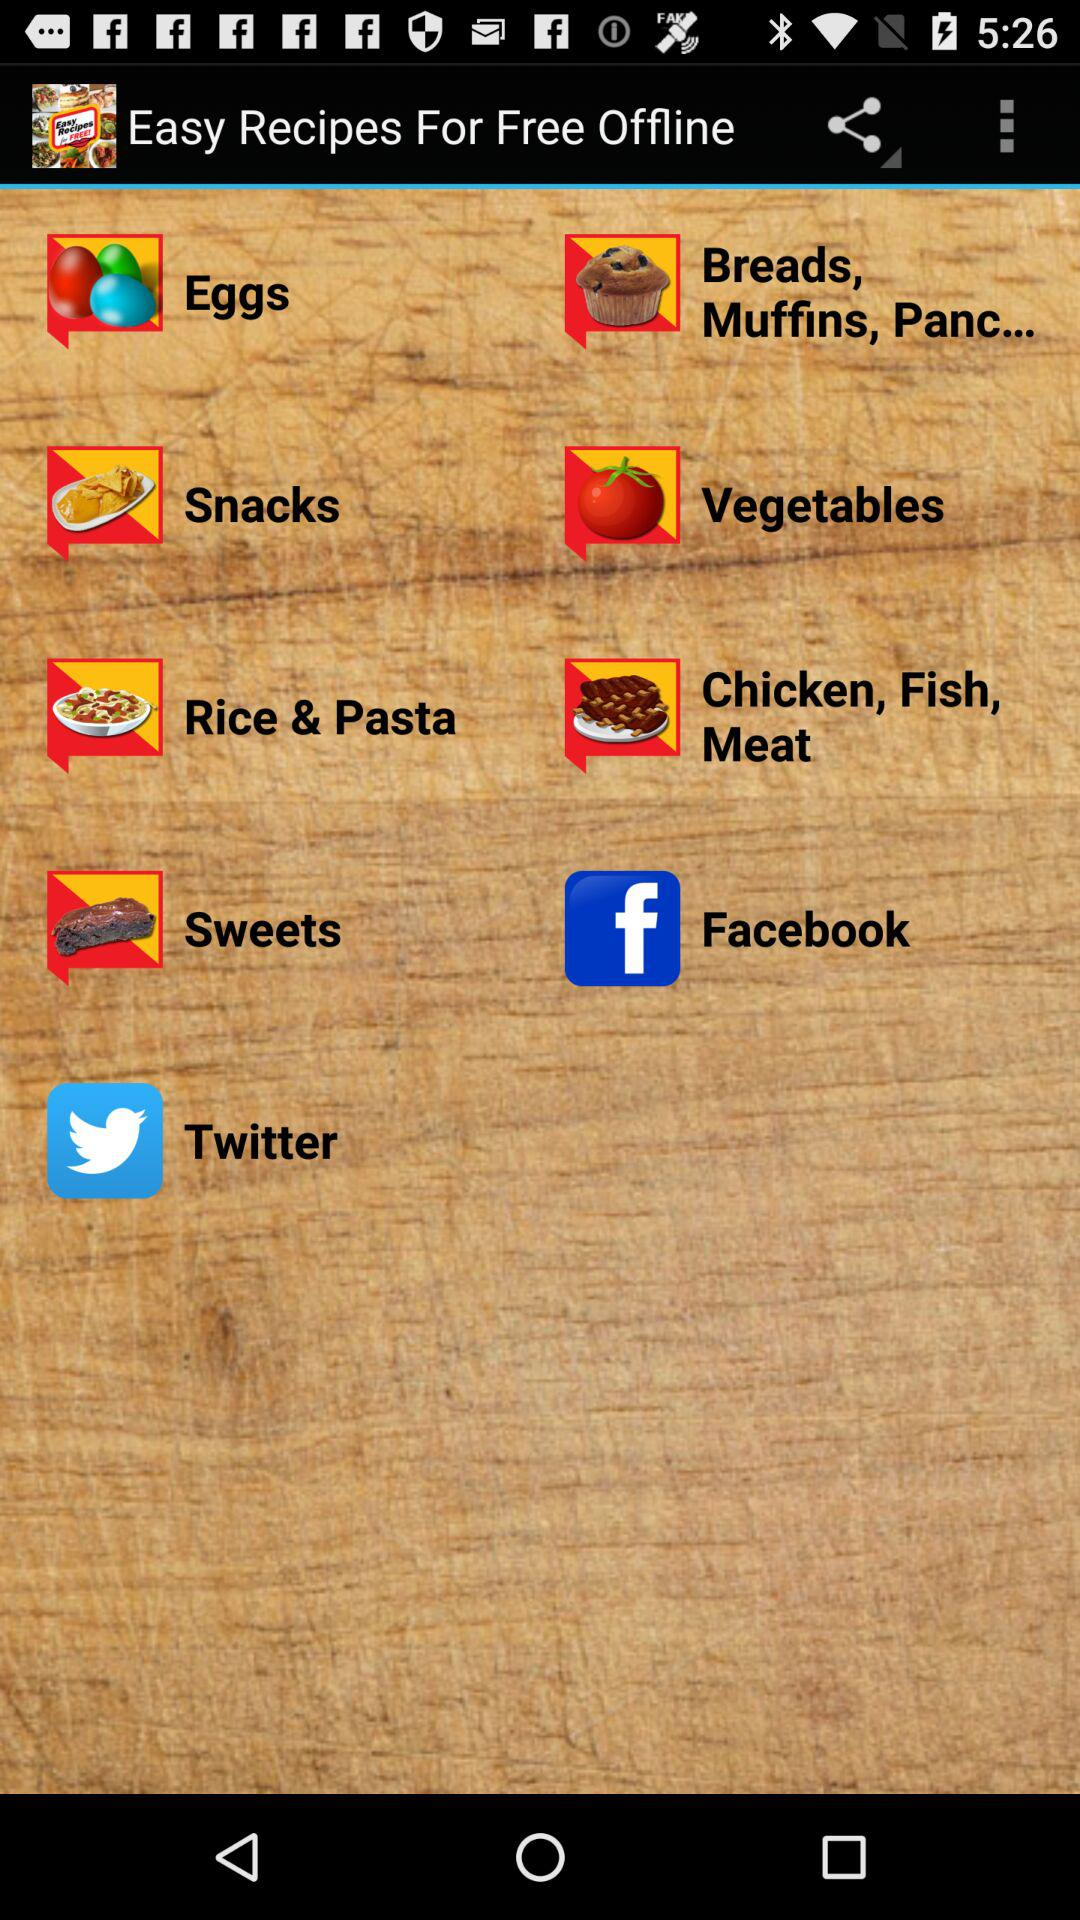Which social networking applications are available? The available social networking applications are "Facebook" and "Twitter". 